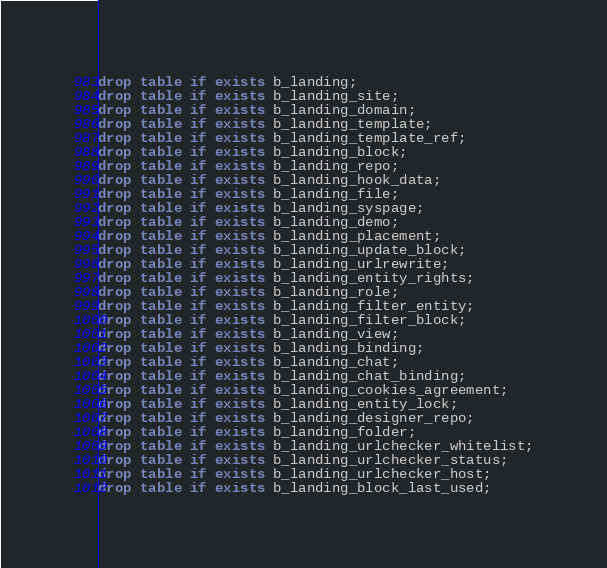<code> <loc_0><loc_0><loc_500><loc_500><_SQL_>drop table if exists b_landing;
drop table if exists b_landing_site;
drop table if exists b_landing_domain;
drop table if exists b_landing_template;
drop table if exists b_landing_template_ref;
drop table if exists b_landing_block;
drop table if exists b_landing_repo;
drop table if exists b_landing_hook_data;
drop table if exists b_landing_file;
drop table if exists b_landing_syspage;
drop table if exists b_landing_demo;
drop table if exists b_landing_placement;
drop table if exists b_landing_update_block;
drop table if exists b_landing_urlrewrite;
drop table if exists b_landing_entity_rights;
drop table if exists b_landing_role;
drop table if exists b_landing_filter_entity;
drop table if exists b_landing_filter_block;
drop table if exists b_landing_view;
drop table if exists b_landing_binding;
drop table if exists b_landing_chat;
drop table if exists b_landing_chat_binding;
drop table if exists b_landing_cookies_agreement;
drop table if exists b_landing_entity_lock;
drop table if exists b_landing_designer_repo;
drop table if exists b_landing_folder;
drop table if exists b_landing_urlchecker_whitelist;
drop table if exists b_landing_urlchecker_status;
drop table if exists b_landing_urlchecker_host;
drop table if exists b_landing_block_last_used;</code> 